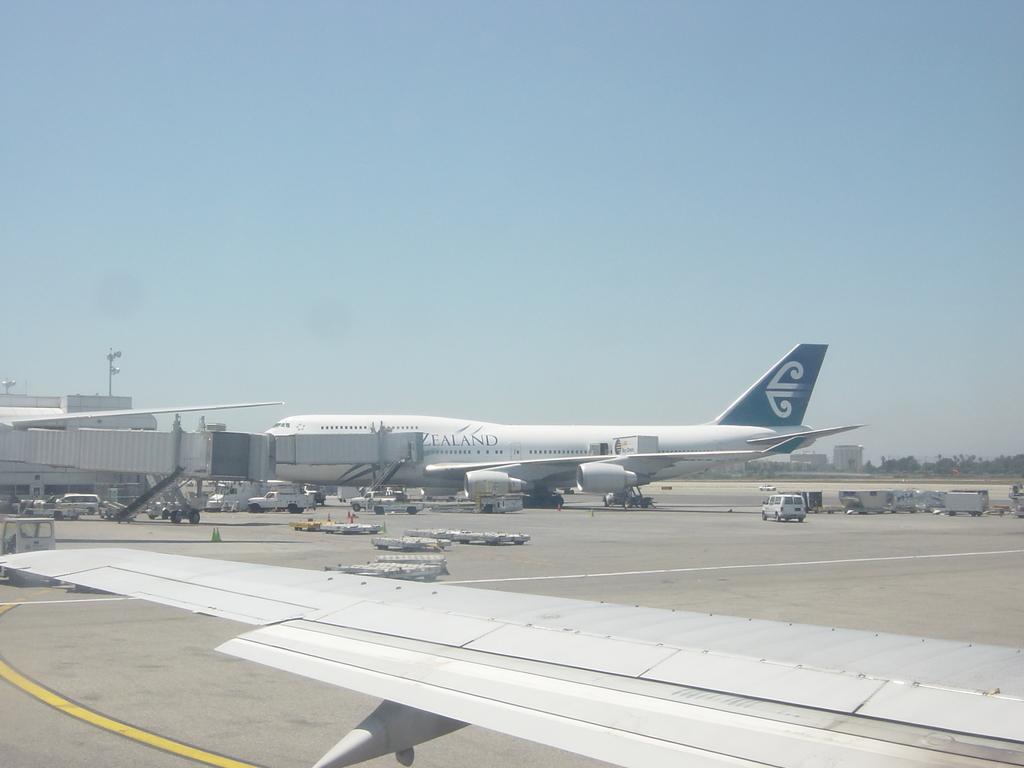In one or two sentences, can you explain what this image depicts? This picture is clicked outside. In the center we can see the aircrafts and we can see the group of vehicles. In the background we can see the sky, buildings, trees and some other objects. 